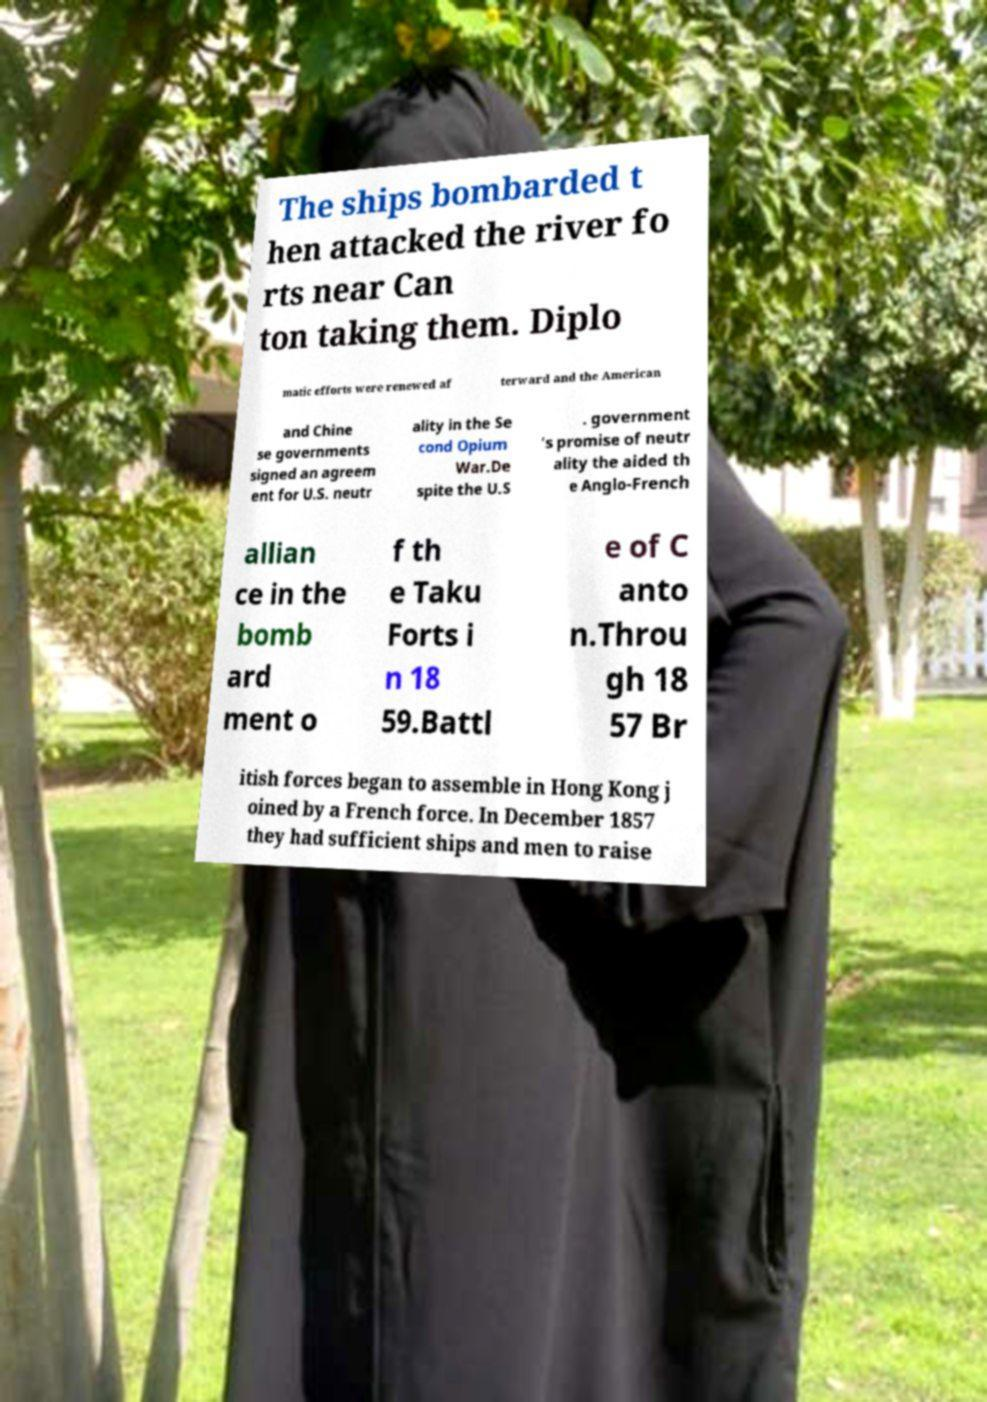For documentation purposes, I need the text within this image transcribed. Could you provide that? The ships bombarded t hen attacked the river fo rts near Can ton taking them. Diplo matic efforts were renewed af terward and the American and Chine se governments signed an agreem ent for U.S. neutr ality in the Se cond Opium War.De spite the U.S . government 's promise of neutr ality the aided th e Anglo-French allian ce in the bomb ard ment o f th e Taku Forts i n 18 59.Battl e of C anto n.Throu gh 18 57 Br itish forces began to assemble in Hong Kong j oined by a French force. In December 1857 they had sufficient ships and men to raise 